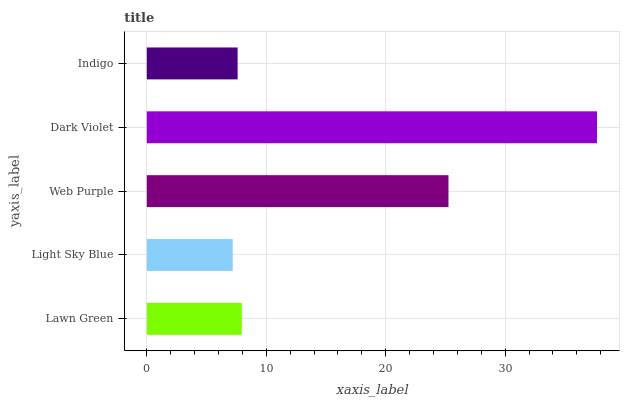Is Light Sky Blue the minimum?
Answer yes or no. Yes. Is Dark Violet the maximum?
Answer yes or no. Yes. Is Web Purple the minimum?
Answer yes or no. No. Is Web Purple the maximum?
Answer yes or no. No. Is Web Purple greater than Light Sky Blue?
Answer yes or no. Yes. Is Light Sky Blue less than Web Purple?
Answer yes or no. Yes. Is Light Sky Blue greater than Web Purple?
Answer yes or no. No. Is Web Purple less than Light Sky Blue?
Answer yes or no. No. Is Lawn Green the high median?
Answer yes or no. Yes. Is Lawn Green the low median?
Answer yes or no. Yes. Is Indigo the high median?
Answer yes or no. No. Is Web Purple the low median?
Answer yes or no. No. 